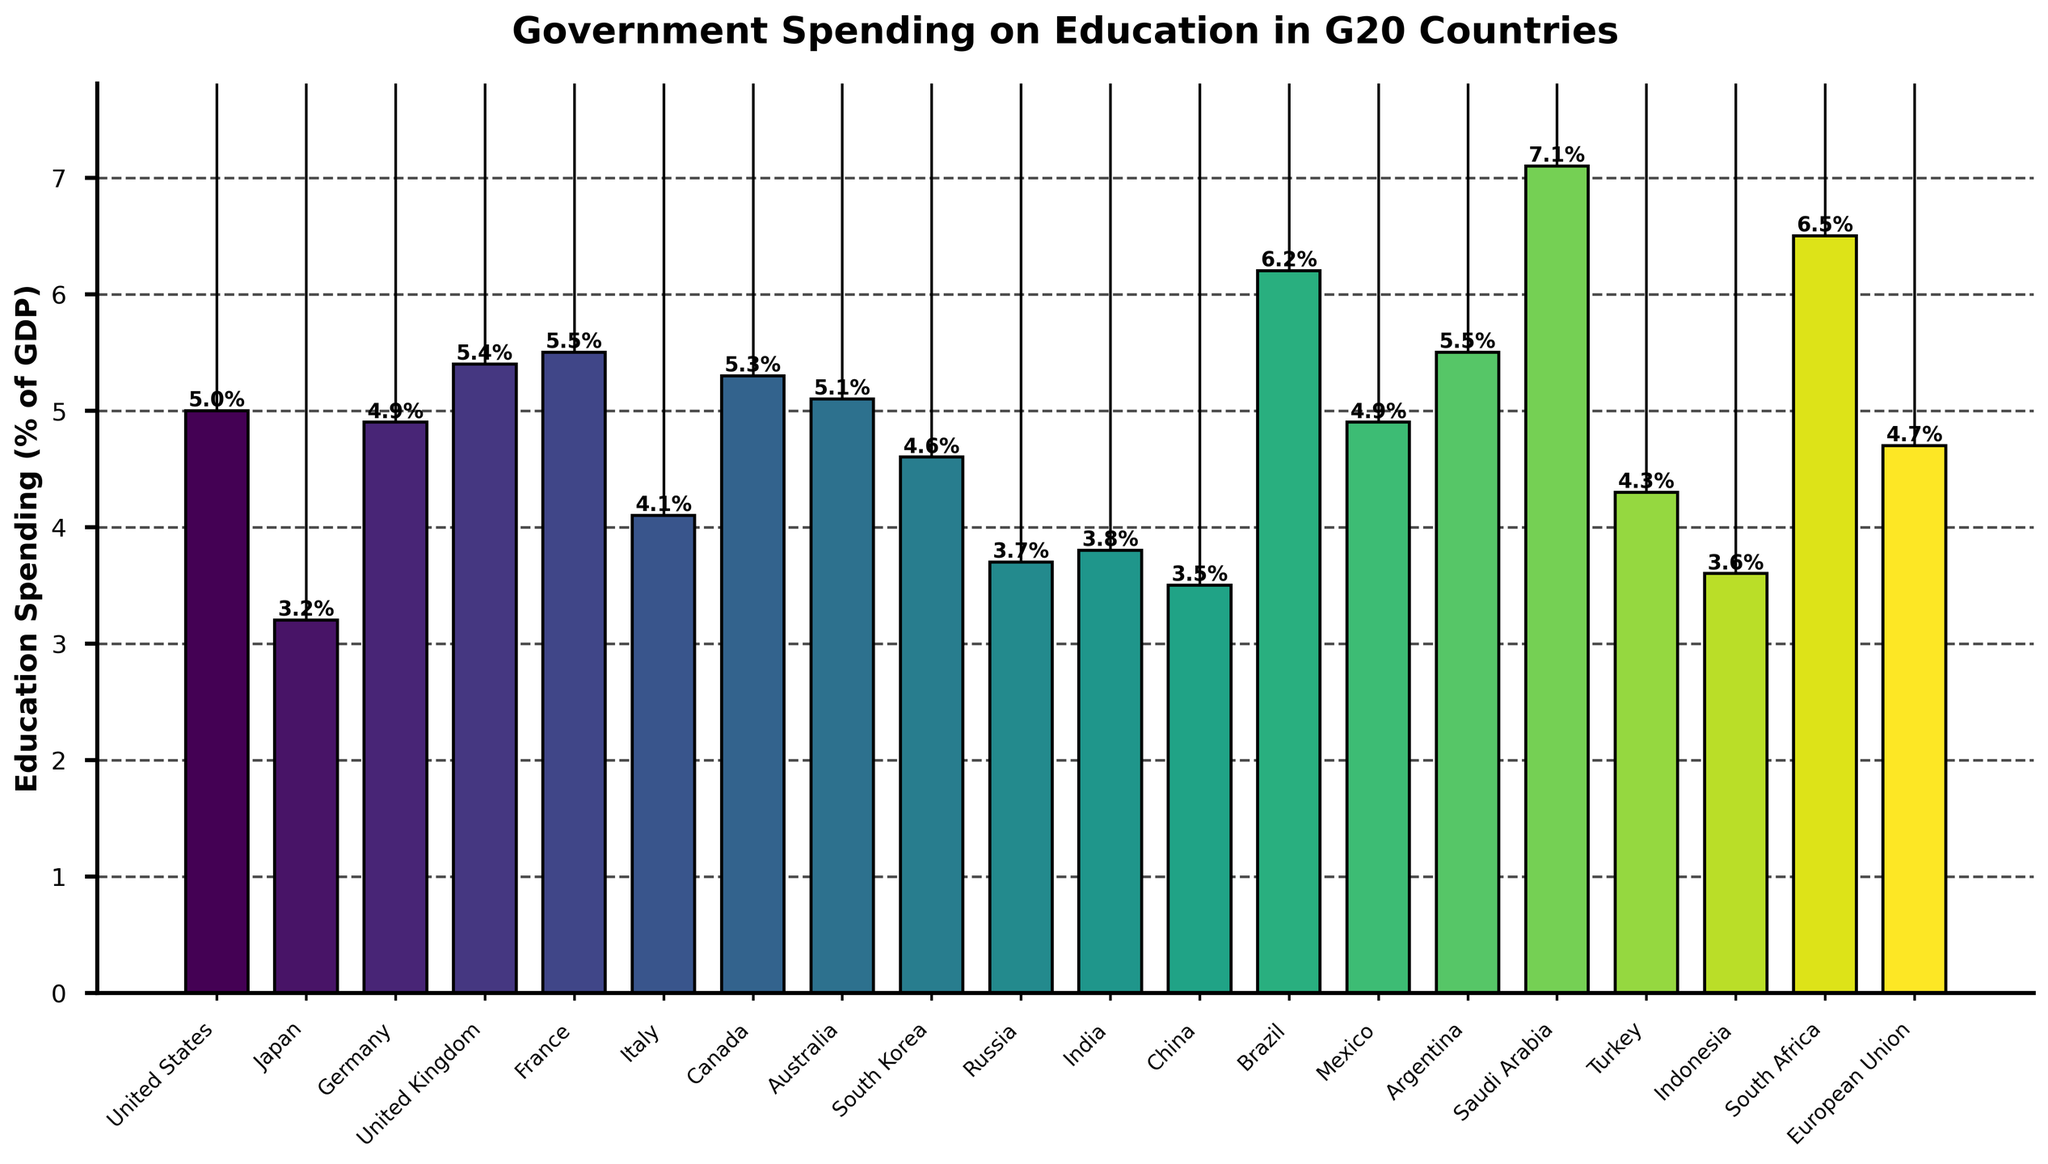What country spent the most on education as a percentage of GDP? From the figure, we can see that Saudi Arabia has the tallest bar, indicating that it spent the highest percentage of GDP on education among G20 countries.
Answer: Saudi Arabia Which countries spent less than 4% of their GDP on education? By examining the heights of the bars in the figure, we see that Japan, Russia, India, China, and Indonesia have bars corresponding to education spending percentages below 4%.
Answer: Japan, Russia, India, China, Indonesia What is the average education spending as a percentage of GDP across all G20 countries shown? To calculate the average, we sum all the percentages and divide by the number of countries. The total is (5.0 + 3.2 + 4.9 + 5.4 + 5.5 + 4.1 + 5.3 + 5.1 + 4.6 + 3.7 + 3.8 + 3.5 + 6.2 + 4.9 + 5.5 + 7.1 + 4.3 + 3.6 + 6.5 + 4.7) = 96.8. There are 20 countries, so the average is 96.8 / 20 = 4.84.
Answer: 4.84 How much more does Brazil spend on education as a percentage of GDP compared to Germany? From the figure, Brazil spends 6.2% while Germany spends 4.9%. The difference is 6.2% - 4.9% = 1.3%.
Answer: 1.3% Rank the top three countries in terms of education spending as a percentage of GDP. By looking at the heights of the bars, the top three countries with the highest spending are Saudi Arabia (7.1%), South Africa (6.5%), and Brazil (6.2%).
Answer: Saudi Arabia, South Africa, Brazil Which country has roughly the same education spending percentage as Canada? From the figure, the bar for the United Kingdom, which is 5.4%, is closest to the bar for Canada, which is 5.3%.
Answer: United Kingdom What is the difference between the highest and the lowest education spending percentages among the G20 countries? The highest percentage is Saudi Arabia with 7.1%, and the lowest is Japan with 3.2%. The difference is 7.1% - 3.2% = 3.9%.
Answer: 3.9% How many countries spend more than 5% of their GDP on education? From the figure, the countries spending more than 5% of GDP on education are the United States (5.0%), United Kingdom (5.4%), France (5.5%), Canada (5.3%), Australia (5.1%), Brazil (6.2%), Argentina (5.5%), Saudi Arabia (7.1%), and South Africa (6.5%). This makes a total of 9 countries.
Answer: 9 Which country falls exactly in the middle of the chart in terms of education spending percentage? To find the median, we sort the percentages and find the middle one. The sorted percentages are: (3.2, 3.5, 3.6, 3.7, 3.8, 4.1, 4.3, 4.6, 4.7, 4.9, 4.9, 5.0, 5.1, 5.3, 5.4, 5.5, 5.5, 6.2, 6.5, 7.1). The middle value is the average of 10th and 11th values (4.9 and 4.9), which is 4.9. Mexico and Germany, both spending 4.9%, fall exactly in the middle.
Answer: Mexico, Germany 